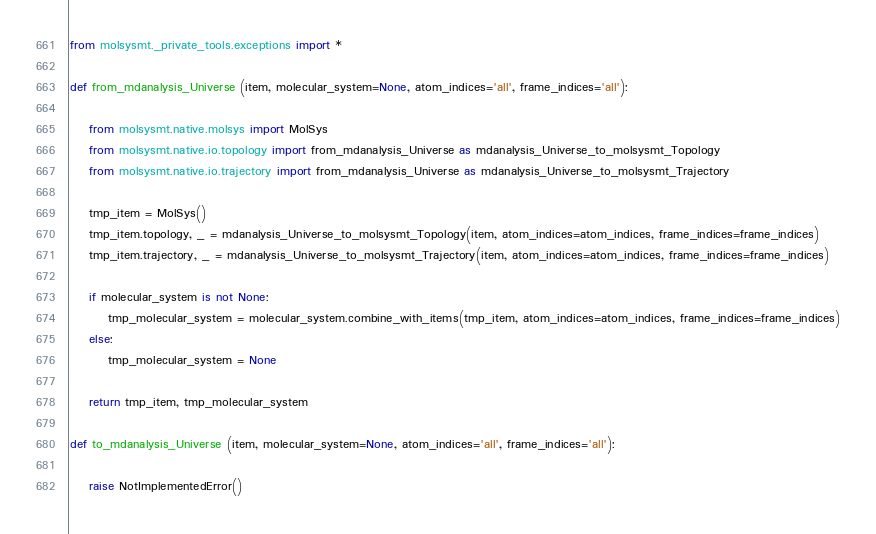<code> <loc_0><loc_0><loc_500><loc_500><_Python_>from molsysmt._private_tools.exceptions import *

def from_mdanalysis_Universe (item, molecular_system=None, atom_indices='all', frame_indices='all'):

    from molsysmt.native.molsys import MolSys
    from molsysmt.native.io.topology import from_mdanalysis_Universe as mdanalysis_Universe_to_molsysmt_Topology
    from molsysmt.native.io.trajectory import from_mdanalysis_Universe as mdanalysis_Universe_to_molsysmt_Trajectory

    tmp_item = MolSys()
    tmp_item.topology, _ = mdanalysis_Universe_to_molsysmt_Topology(item, atom_indices=atom_indices, frame_indices=frame_indices)
    tmp_item.trajectory, _ = mdanalysis_Universe_to_molsysmt_Trajectory(item, atom_indices=atom_indices, frame_indices=frame_indices)

    if molecular_system is not None:
        tmp_molecular_system = molecular_system.combine_with_items(tmp_item, atom_indices=atom_indices, frame_indices=frame_indices)
    else:
        tmp_molecular_system = None

    return tmp_item, tmp_molecular_system

def to_mdanalysis_Universe (item, molecular_system=None, atom_indices='all', frame_indices='all'):

    raise NotImplementedError()

</code> 